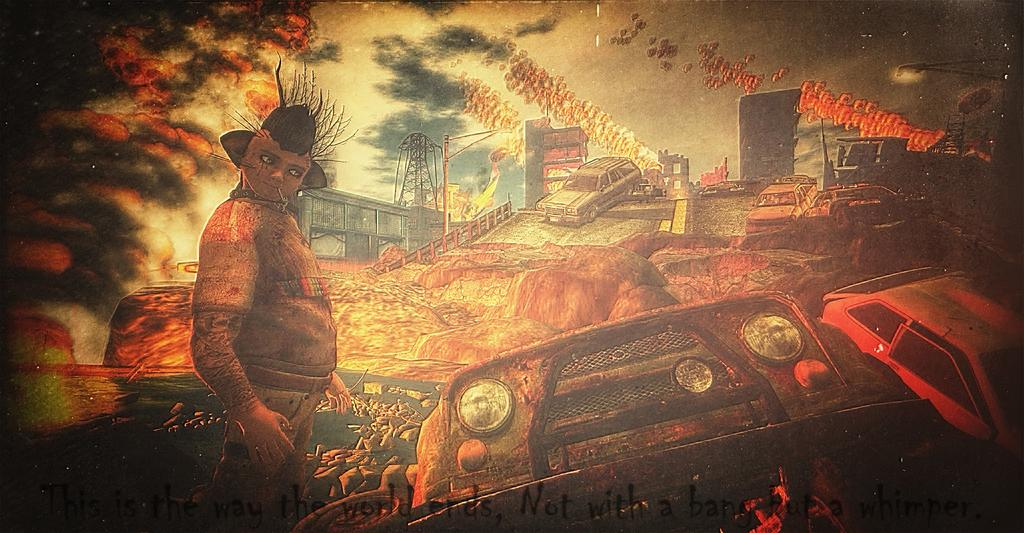What type of visual is shown in the image? The image appears to be a poster. What is the main subject of the poster? The poster depicts a person. What other objects or elements can be seen on the poster? There are vehicles, a tree, an electric steel tower, and the sky visible on the poster. Is there any text on the poster? Yes, there is text written on the poster. How many drawers are visible on the poster? There are no drawers present on the poster. What type of leg is shown supporting the person on the poster? There is no leg shown supporting the person on the poster; it is a two-dimensional image. 